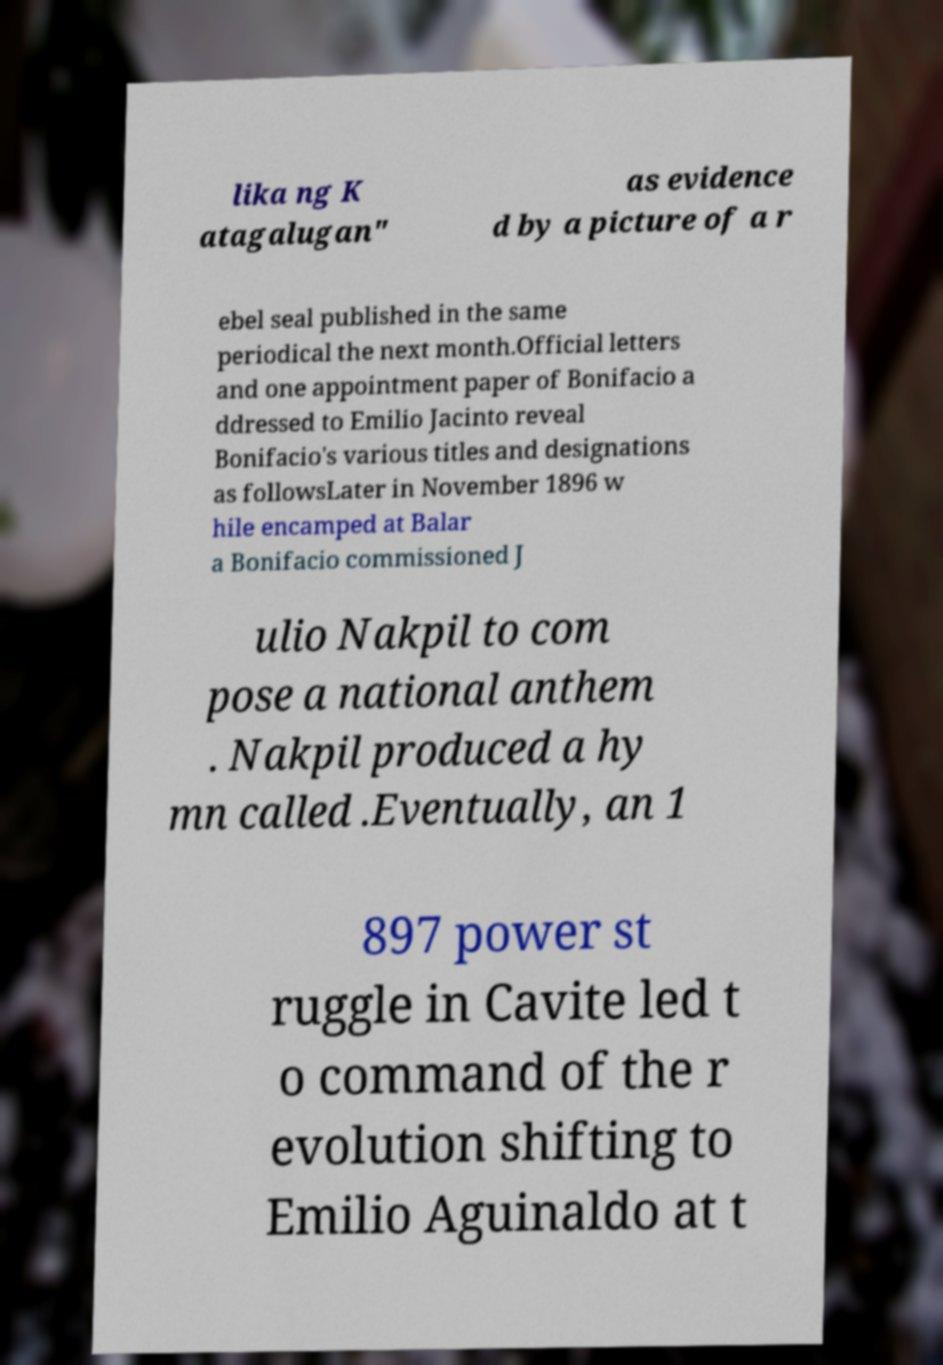For documentation purposes, I need the text within this image transcribed. Could you provide that? lika ng K atagalugan" as evidence d by a picture of a r ebel seal published in the same periodical the next month.Official letters and one appointment paper of Bonifacio a ddressed to Emilio Jacinto reveal Bonifacio's various titles and designations as followsLater in November 1896 w hile encamped at Balar a Bonifacio commissioned J ulio Nakpil to com pose a national anthem . Nakpil produced a hy mn called .Eventually, an 1 897 power st ruggle in Cavite led t o command of the r evolution shifting to Emilio Aguinaldo at t 